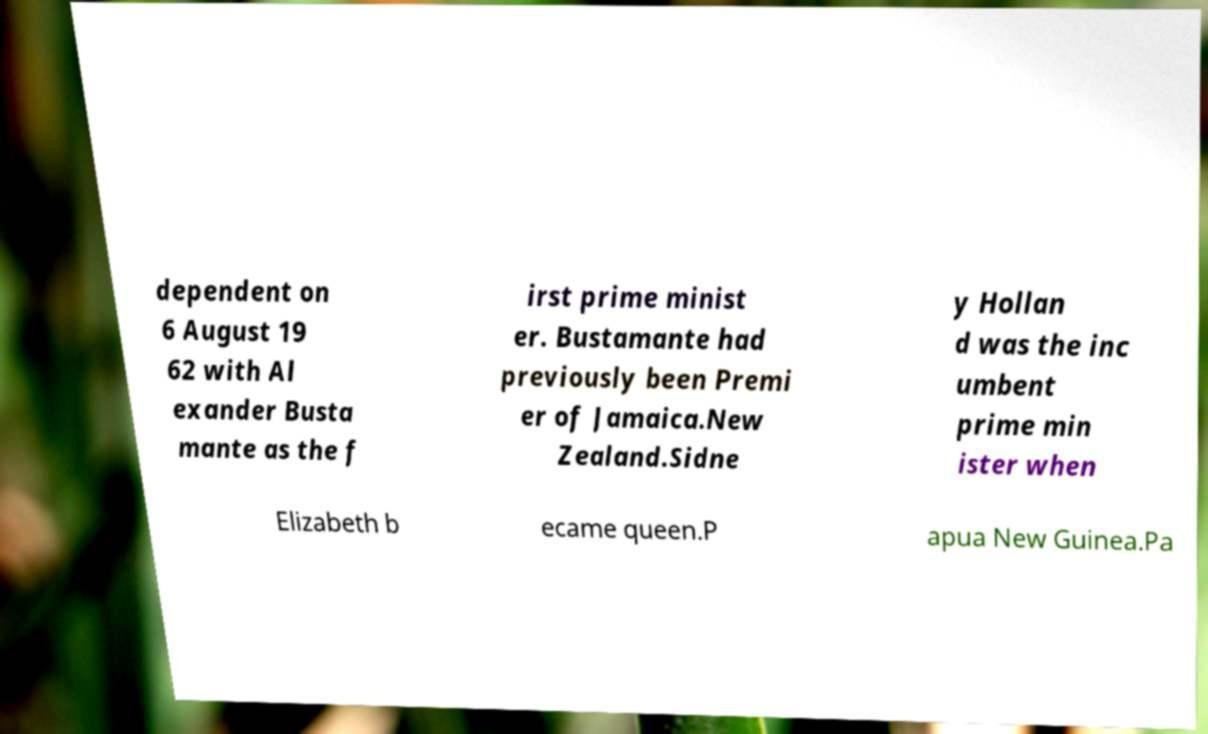Please identify and transcribe the text found in this image. dependent on 6 August 19 62 with Al exander Busta mante as the f irst prime minist er. Bustamante had previously been Premi er of Jamaica.New Zealand.Sidne y Hollan d was the inc umbent prime min ister when Elizabeth b ecame queen.P apua New Guinea.Pa 